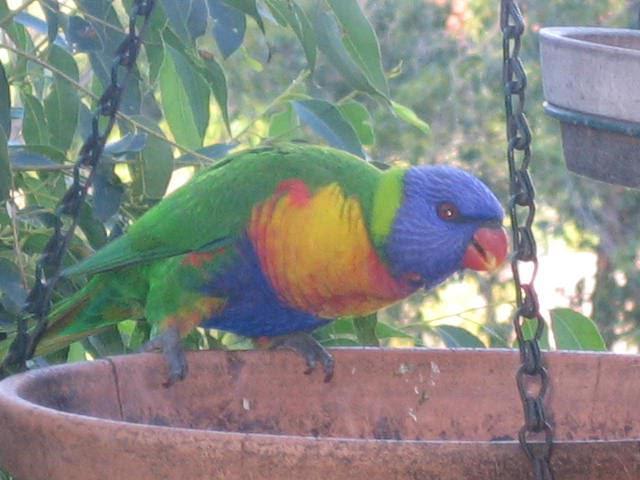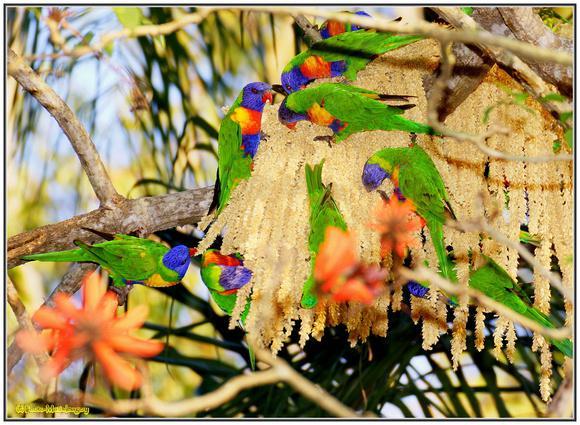The first image is the image on the left, the second image is the image on the right. For the images shown, is this caption "Left and right images each show no more than two birds, and all images show a bird near a hollow in a tree." true? Answer yes or no. No. The first image is the image on the left, the second image is the image on the right. Examine the images to the left and right. Is the description "The right image contains at least three parrots." accurate? Answer yes or no. Yes. 